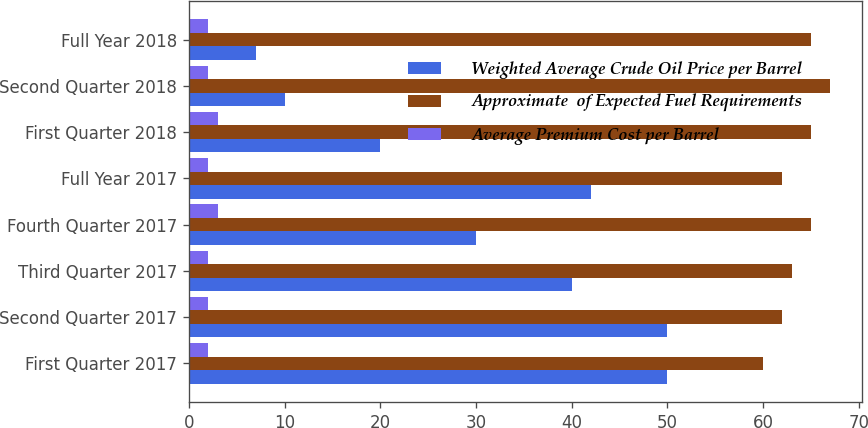<chart> <loc_0><loc_0><loc_500><loc_500><stacked_bar_chart><ecel><fcel>First Quarter 2017<fcel>Second Quarter 2017<fcel>Third Quarter 2017<fcel>Fourth Quarter 2017<fcel>Full Year 2017<fcel>First Quarter 2018<fcel>Second Quarter 2018<fcel>Full Year 2018<nl><fcel>Weighted Average Crude Oil Price per Barrel<fcel>50<fcel>50<fcel>40<fcel>30<fcel>42<fcel>20<fcel>10<fcel>7<nl><fcel>Approximate  of Expected Fuel Requirements<fcel>60<fcel>62<fcel>63<fcel>65<fcel>62<fcel>65<fcel>67<fcel>65<nl><fcel>Average Premium Cost per Barrel<fcel>2<fcel>2<fcel>2<fcel>3<fcel>2<fcel>3<fcel>2<fcel>2<nl></chart> 